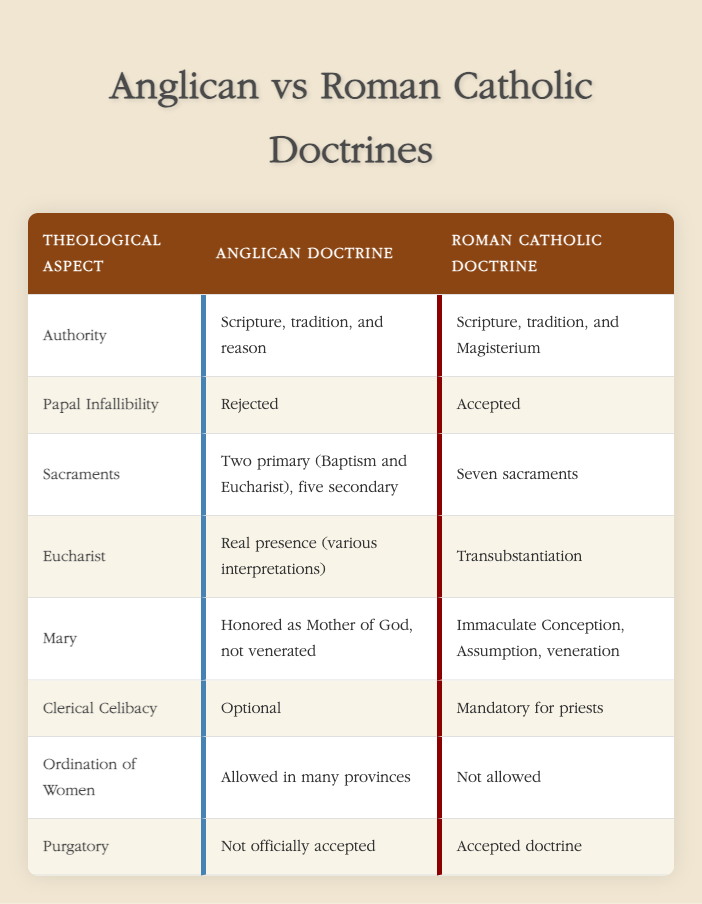What is the Anglican view on the authority of Scripture? According to the table, the Anglican doctrine states that authority comes from Scripture, tradition, and reason.
Answer: Scripture, tradition, and reason How many sacraments does the Roman Catholic Church recognize? The table clearly states that the Roman Catholic doctrine recognizes seven sacraments.
Answer: Seven sacraments Is papal infallibility accepted in Anglican doctrine? The table indicates that the Anglican doctrine rejects papal infallibility, making the answer "no".
Answer: No What is the difference in the view of Mary between the two churches? The Anglican doctrine honors Mary as the Mother of God but does not venerate her, while the Roman Catholic doctrine includes beliefs in her Immaculate Conception and Assumption, along with veneration.
Answer: Anglican honors; Catholic veneration How many primary sacraments do Anglicans recognize compared to Catholics? Anglicans recognize two primary sacraments (Baptism and Eucharist), whereas Catholics recognize seven. The difference is 5 sacraments.
Answer: 5 sacraments difference Does the Anglican Church allow the ordination of women? The table shows that the Anglican doctrine allows the ordination of women in many provinces, indicating a "yes" answer.
Answer: Yes In what aspect does the Anglican Church differ significantly from the Catholic Church in terms of clerical celibacy? The Anglican doctrine allows optional celibacy for priests, while the Roman Catholic doctrine mandates it. This shows a clear divergence in their positions on clerical celibacy requirements.
Answer: Optional vs. mandatory Is the concept of purgatory accepted in Anglican doctrine? The table states that purgatory is not officially accepted in Anglican doctrine, hence the answer is "no".
Answer: No What are the interpretations of the Eucharist in Anglican doctrine? The table shows that Anglicans believe in the real presence of Christ in the Eucharist, though there are various interpretations.
Answer: Real presence (various interpretations) 